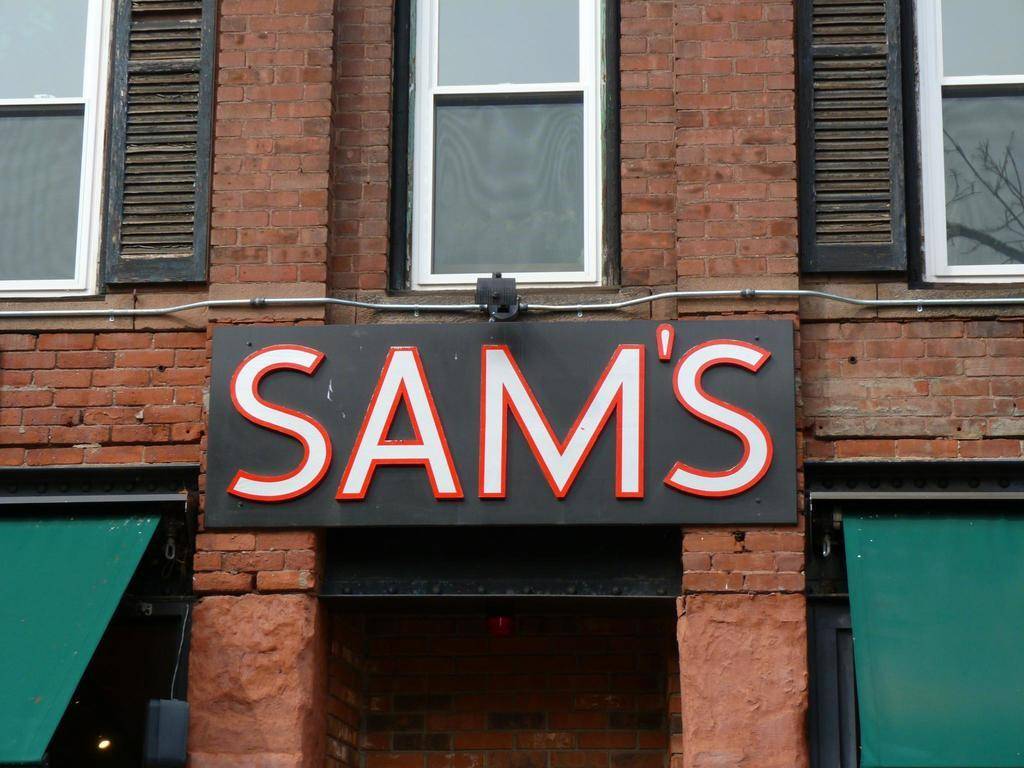<image>
Share a concise interpretation of the image provided. The front of a brick business named "Sam's". 